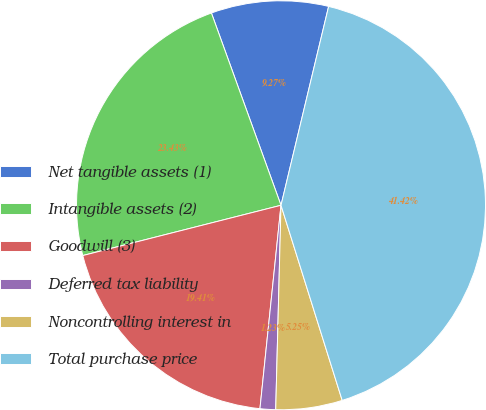<chart> <loc_0><loc_0><loc_500><loc_500><pie_chart><fcel>Net tangible assets (1)<fcel>Intangible assets (2)<fcel>Goodwill (3)<fcel>Deferred tax liability<fcel>Noncontrolling interest in<fcel>Total purchase price<nl><fcel>9.27%<fcel>23.43%<fcel>19.41%<fcel>1.23%<fcel>5.25%<fcel>41.43%<nl></chart> 